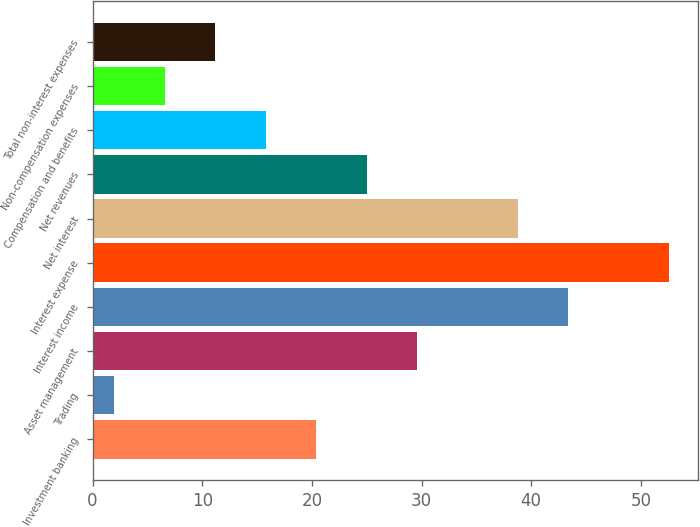Convert chart to OTSL. <chart><loc_0><loc_0><loc_500><loc_500><bar_chart><fcel>Investment banking<fcel>Trading<fcel>Asset management<fcel>Interest income<fcel>Interest expense<fcel>Net interest<fcel>Net revenues<fcel>Compensation and benefits<fcel>Non-compensation expenses<fcel>Total non-interest expenses<nl><fcel>20.4<fcel>2<fcel>29.6<fcel>43.4<fcel>52.6<fcel>38.8<fcel>25<fcel>15.8<fcel>6.6<fcel>11.2<nl></chart> 